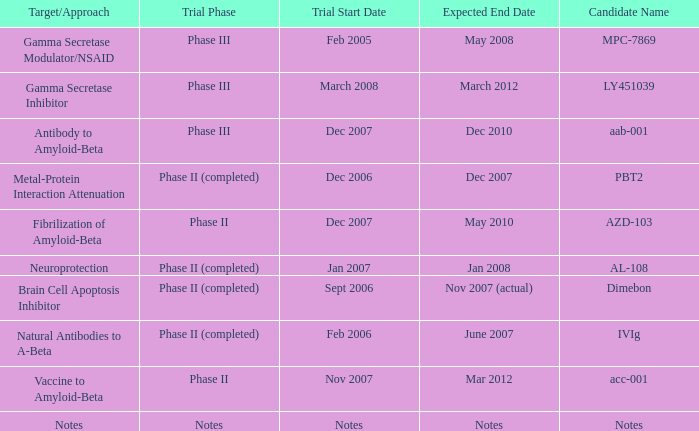What is Expected End Date, when Target/Approach is Notes? Notes. 